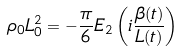<formula> <loc_0><loc_0><loc_500><loc_500>\rho _ { 0 } L _ { 0 } ^ { 2 } = - \frac { \pi } { 6 } E _ { 2 } \left ( i \frac { \beta ( t ) } { L ( t ) } \right )</formula> 